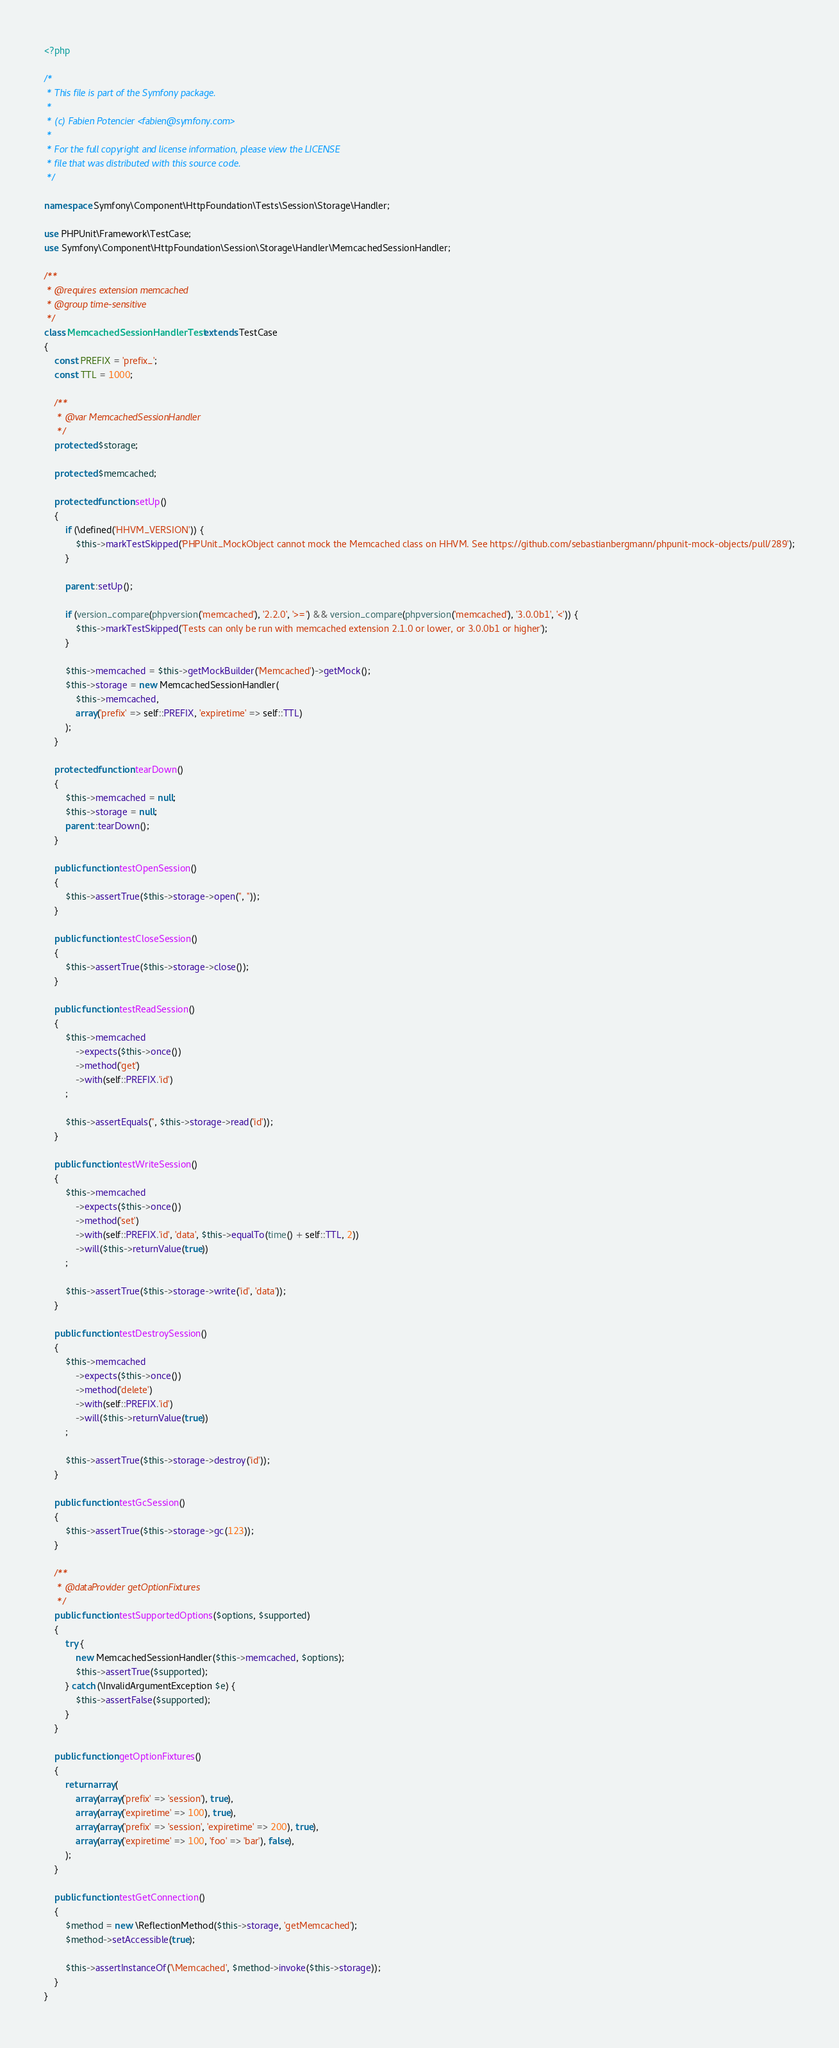Convert code to text. <code><loc_0><loc_0><loc_500><loc_500><_PHP_><?php

/*
 * This file is part of the Symfony package.
 *
 * (c) Fabien Potencier <fabien@symfony.com>
 *
 * For the full copyright and license information, please view the LICENSE
 * file that was distributed with this source code.
 */

namespace Symfony\Component\HttpFoundation\Tests\Session\Storage\Handler;

use PHPUnit\Framework\TestCase;
use Symfony\Component\HttpFoundation\Session\Storage\Handler\MemcachedSessionHandler;

/**
 * @requires extension memcached
 * @group time-sensitive
 */
class MemcachedSessionHandlerTest extends TestCase
{
    const PREFIX = 'prefix_';
    const TTL = 1000;

    /**
     * @var MemcachedSessionHandler
     */
    protected $storage;

    protected $memcached;

    protected function setUp()
    {
        if (\defined('HHVM_VERSION')) {
            $this->markTestSkipped('PHPUnit_MockObject cannot mock the Memcached class on HHVM. See https://github.com/sebastianbergmann/phpunit-mock-objects/pull/289');
        }

        parent::setUp();

        if (version_compare(phpversion('memcached'), '2.2.0', '>=') && version_compare(phpversion('memcached'), '3.0.0b1', '<')) {
            $this->markTestSkipped('Tests can only be run with memcached extension 2.1.0 or lower, or 3.0.0b1 or higher');
        }

        $this->memcached = $this->getMockBuilder('Memcached')->getMock();
        $this->storage = new MemcachedSessionHandler(
            $this->memcached,
            array('prefix' => self::PREFIX, 'expiretime' => self::TTL)
        );
    }

    protected function tearDown()
    {
        $this->memcached = null;
        $this->storage = null;
        parent::tearDown();
    }

    public function testOpenSession()
    {
        $this->assertTrue($this->storage->open('', ''));
    }

    public function testCloseSession()
    {
        $this->assertTrue($this->storage->close());
    }

    public function testReadSession()
    {
        $this->memcached
            ->expects($this->once())
            ->method('get')
            ->with(self::PREFIX.'id')
        ;

        $this->assertEquals('', $this->storage->read('id'));
    }

    public function testWriteSession()
    {
        $this->memcached
            ->expects($this->once())
            ->method('set')
            ->with(self::PREFIX.'id', 'data', $this->equalTo(time() + self::TTL, 2))
            ->will($this->returnValue(true))
        ;

        $this->assertTrue($this->storage->write('id', 'data'));
    }

    public function testDestroySession()
    {
        $this->memcached
            ->expects($this->once())
            ->method('delete')
            ->with(self::PREFIX.'id')
            ->will($this->returnValue(true))
        ;

        $this->assertTrue($this->storage->destroy('id'));
    }

    public function testGcSession()
    {
        $this->assertTrue($this->storage->gc(123));
    }

    /**
     * @dataProvider getOptionFixtures
     */
    public function testSupportedOptions($options, $supported)
    {
        try {
            new MemcachedSessionHandler($this->memcached, $options);
            $this->assertTrue($supported);
        } catch (\InvalidArgumentException $e) {
            $this->assertFalse($supported);
        }
    }

    public function getOptionFixtures()
    {
        return array(
            array(array('prefix' => 'session'), true),
            array(array('expiretime' => 100), true),
            array(array('prefix' => 'session', 'expiretime' => 200), true),
            array(array('expiretime' => 100, 'foo' => 'bar'), false),
        );
    }

    public function testGetConnection()
    {
        $method = new \ReflectionMethod($this->storage, 'getMemcached');
        $method->setAccessible(true);

        $this->assertInstanceOf('\Memcached', $method->invoke($this->storage));
    }
}
</code> 